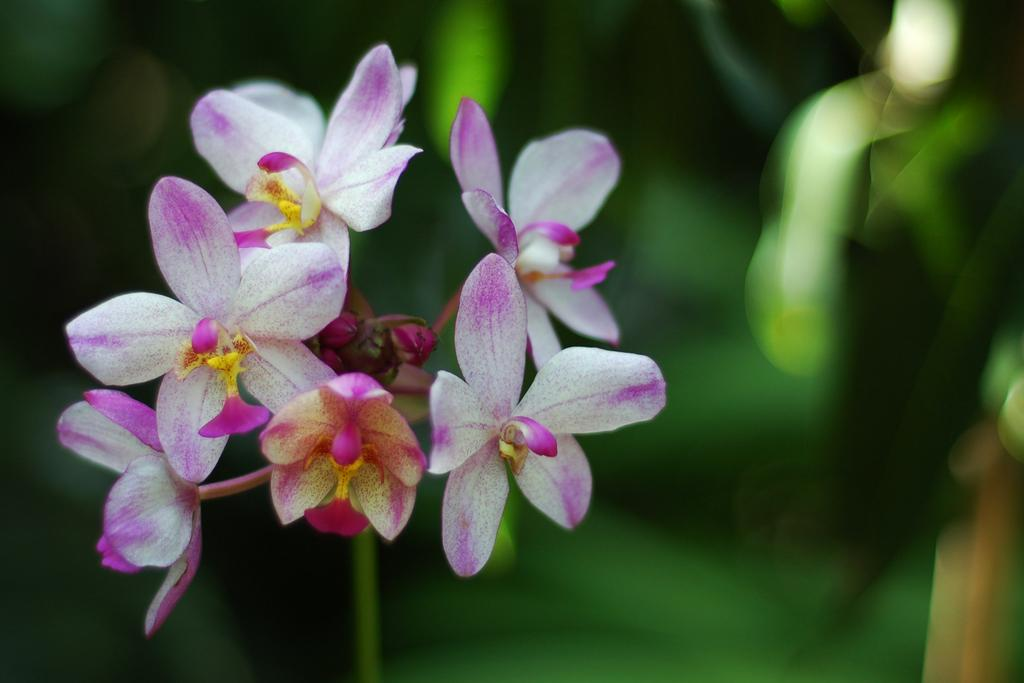What type of flora can be seen on the left side of the image? There are flowers on the left side of the image. Can you tell me how many doctors are present in the image? There are no doctors present in the image; it only features flowers on the left side. What type of action is being performed on the flowers in the image? There is no action being performed on the flowers in the image; they are simply depicted as they are. 